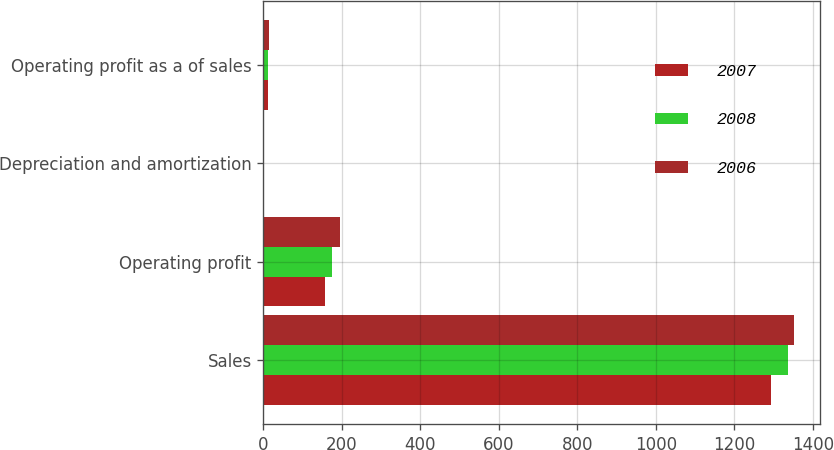Convert chart to OTSL. <chart><loc_0><loc_0><loc_500><loc_500><stacked_bar_chart><ecel><fcel>Sales<fcel>Operating profit<fcel>Depreciation and amortization<fcel>Operating profit as a of sales<nl><fcel>2007<fcel>1294.2<fcel>157.7<fcel>1.6<fcel>12.2<nl><fcel>2008<fcel>1336.6<fcel>175.6<fcel>1.6<fcel>13.1<nl><fcel>2006<fcel>1350.8<fcel>194.1<fcel>1.6<fcel>14.4<nl></chart> 